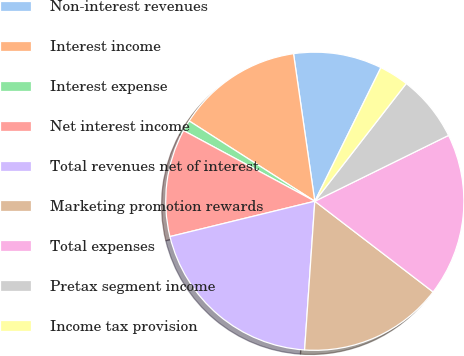Convert chart to OTSL. <chart><loc_0><loc_0><loc_500><loc_500><pie_chart><fcel>Non-interest revenues<fcel>Interest income<fcel>Interest expense<fcel>Net interest income<fcel>Total revenues net of interest<fcel>Marketing promotion rewards<fcel>Total expenses<fcel>Pretax segment income<fcel>Income tax provision<nl><fcel>9.59%<fcel>13.67%<fcel>1.19%<fcel>11.67%<fcel>20.1%<fcel>15.68%<fcel>17.69%<fcel>7.21%<fcel>3.2%<nl></chart> 